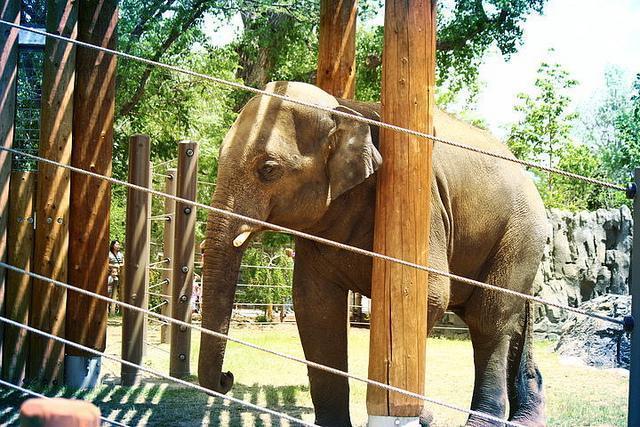How many legs does this elephant have?
Give a very brief answer. 4. How many windows on this airplane are touched by red or orange paint?
Give a very brief answer. 0. 